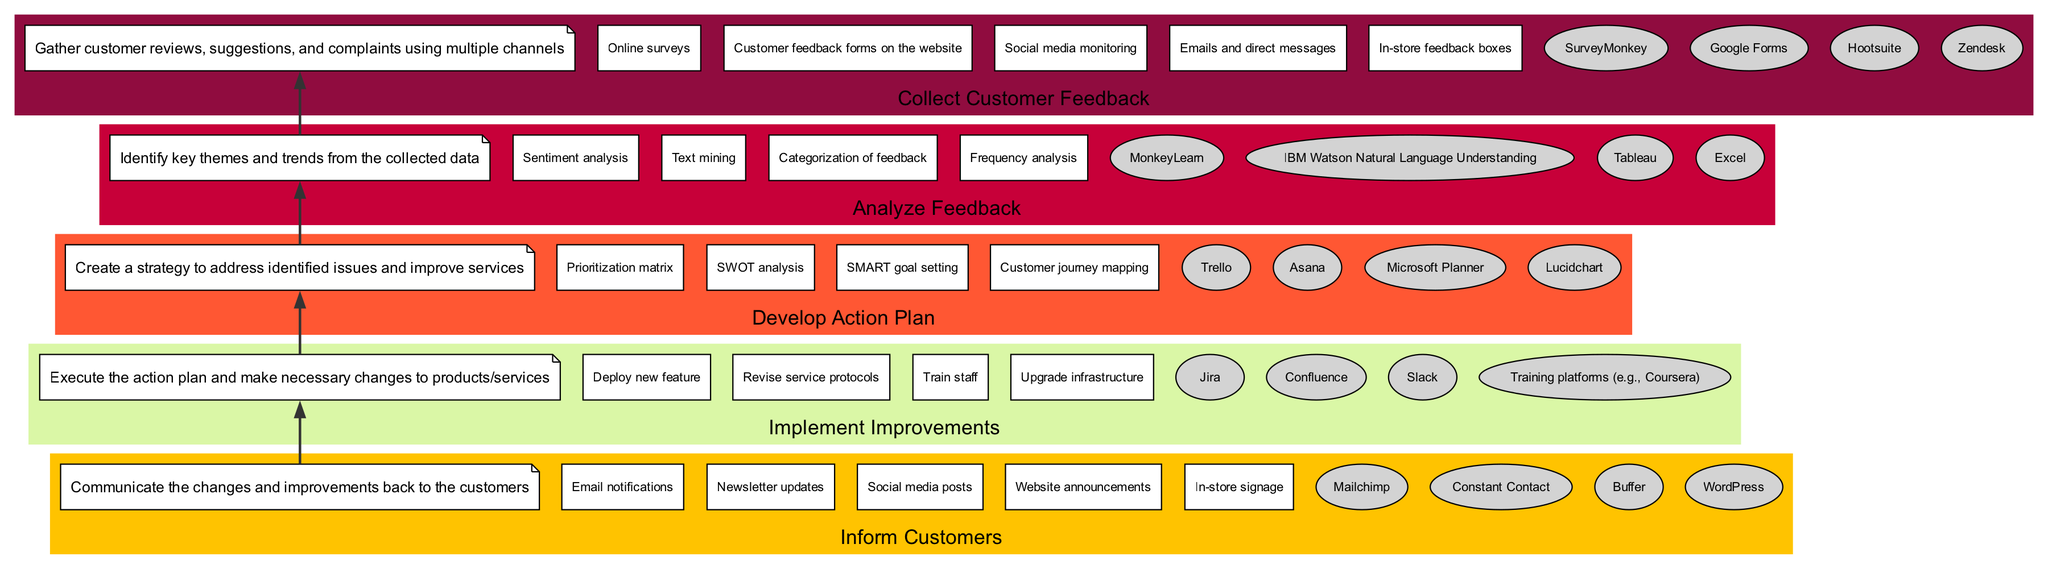What is the first stage in the customer feedback loop? The diagram indicates that the first stage at the bottom is "Collect Customer Feedback." This is established by starting from the base of the flowchart and identifying the first labeled stage as per the diagram's structure.
Answer: Collect Customer Feedback How many methods are listed under the "Analyze Feedback" stage? By examining the "Analyze Feedback" stage in the diagram, there are four methods listed. This is confirmed by counting each method associated with that stage in the visual representation.
Answer: Four What tools are used in the stage "Implement Improvements"? The stage "Implement Improvements" contains four different tools listed underneath it in the diagram. This is identified by looking at the tools specifically associated with that stage.
Answer: Jira, Confluence, Slack, Training platforms What is the relationship between "Develop Action Plan" and "Inform Customers"? The relationship is that "Develop Action Plan" precedes "Inform Customers" in the flow, indicating that one must develop an action plan before informing customers of any changes. This can be traced through the arrows connecting the two stages in the diagram.
Answer: "Develop Action Plan" leads to "Inform Customers" Which stage employs "SWOT analysis"? The "Develop Action Plan" stage employs "SWOT analysis," which is clearly stated under the methods section for that particular stage in the diagram. This can be determined by looking at the specific methods utilized within that stage.
Answer: Develop Action Plan What is the color associated with the "Collect Customer Feedback" stage? The color associated with the "Collect Customer Feedback" stage is yellow, identified by visual inspection of the colored section of the diagram that represents that specific stage.
Answer: Yellow How many total stages are there in the customer feedback loop? The diagram lists five distinct stages in the customer feedback loop, which can be counted by identifying each labeled section within the diagram.
Answer: Five Which method involves analyzing the sentiment of customer feedback? The method that involves analyzing sentiment is "Sentiment analysis," which is specifically mentioned under the "Analyze Feedback" stage. This can be found by examining the list of methods labeled in that stage.
Answer: Sentiment analysis 